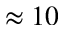<formula> <loc_0><loc_0><loc_500><loc_500>\approx 1 0</formula> 